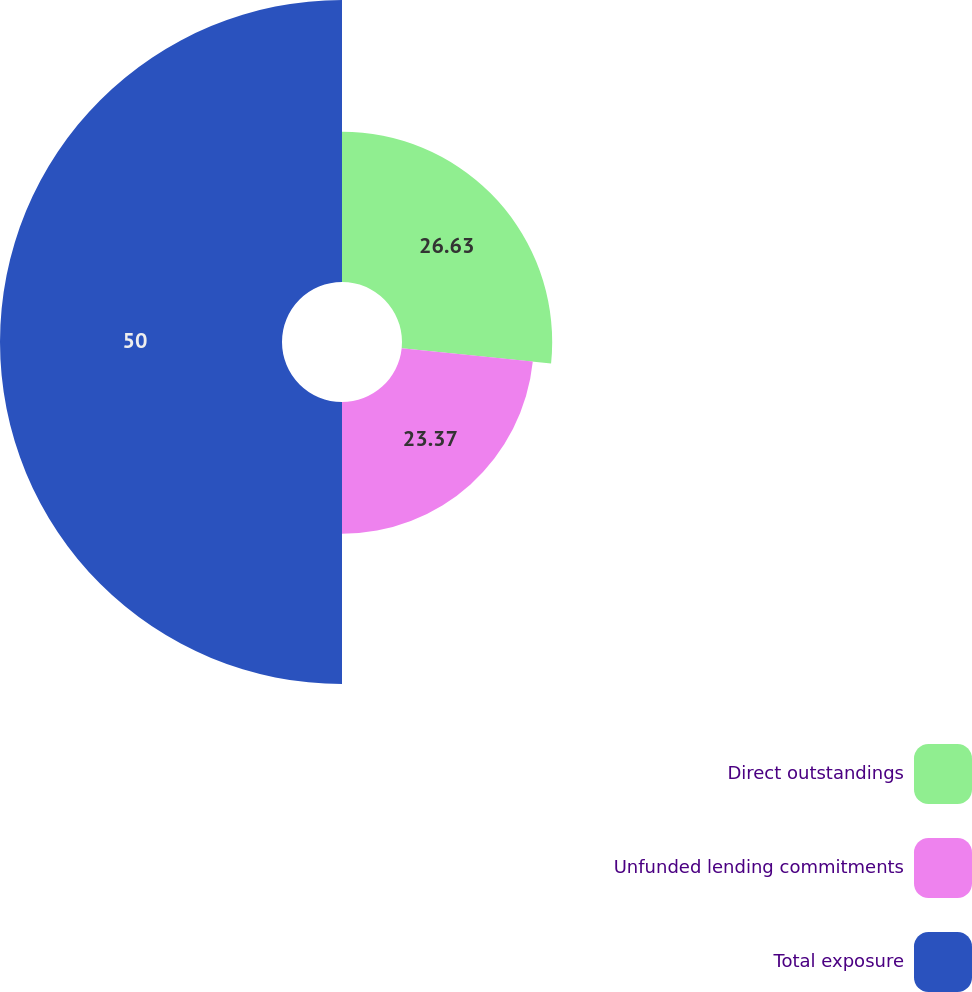Convert chart to OTSL. <chart><loc_0><loc_0><loc_500><loc_500><pie_chart><fcel>Direct outstandings<fcel>Unfunded lending commitments<fcel>Total exposure<nl><fcel>26.63%<fcel>23.37%<fcel>50.0%<nl></chart> 